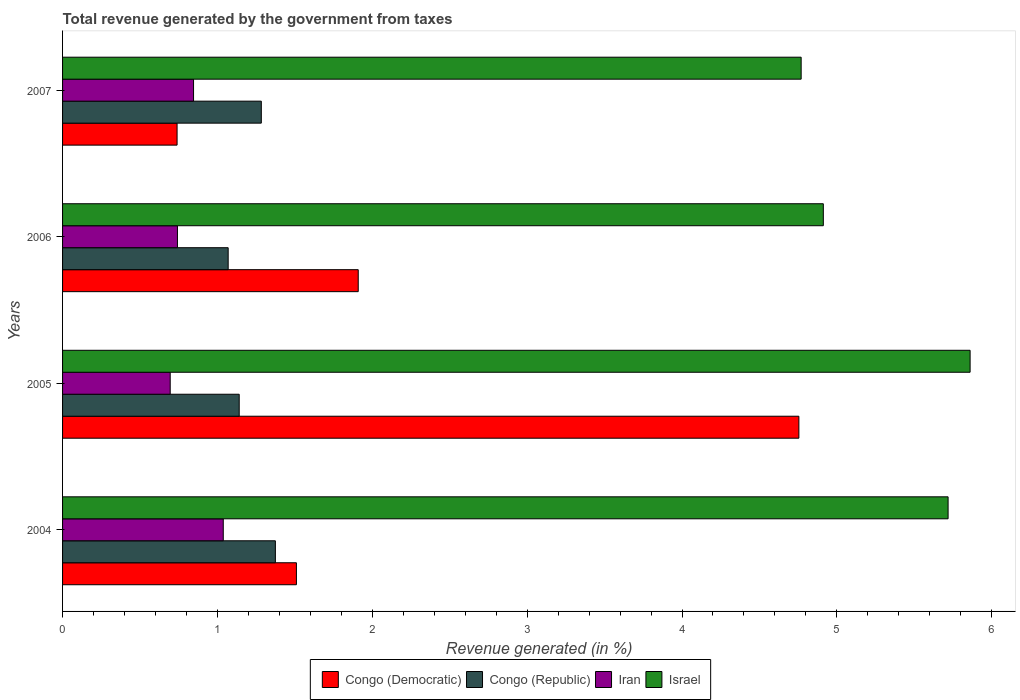How many different coloured bars are there?
Make the answer very short. 4. How many groups of bars are there?
Offer a very short reply. 4. Are the number of bars per tick equal to the number of legend labels?
Offer a very short reply. Yes. What is the total revenue generated in Israel in 2005?
Your answer should be compact. 5.86. Across all years, what is the maximum total revenue generated in Congo (Republic)?
Give a very brief answer. 1.37. Across all years, what is the minimum total revenue generated in Congo (Republic)?
Offer a terse response. 1.07. In which year was the total revenue generated in Israel maximum?
Provide a succinct answer. 2005. What is the total total revenue generated in Congo (Democratic) in the graph?
Your answer should be compact. 8.91. What is the difference between the total revenue generated in Congo (Republic) in 2004 and that in 2005?
Offer a very short reply. 0.23. What is the difference between the total revenue generated in Iran in 2005 and the total revenue generated in Congo (Republic) in 2007?
Make the answer very short. -0.59. What is the average total revenue generated in Iran per year?
Provide a succinct answer. 0.83. In the year 2007, what is the difference between the total revenue generated in Iran and total revenue generated in Israel?
Your answer should be compact. -3.92. What is the ratio of the total revenue generated in Iran in 2004 to that in 2005?
Make the answer very short. 1.49. Is the difference between the total revenue generated in Iran in 2005 and 2007 greater than the difference between the total revenue generated in Israel in 2005 and 2007?
Give a very brief answer. No. What is the difference between the highest and the second highest total revenue generated in Congo (Republic)?
Offer a very short reply. 0.09. What is the difference between the highest and the lowest total revenue generated in Israel?
Make the answer very short. 1.09. Is the sum of the total revenue generated in Congo (Republic) in 2004 and 2006 greater than the maximum total revenue generated in Israel across all years?
Keep it short and to the point. No. Is it the case that in every year, the sum of the total revenue generated in Congo (Democratic) and total revenue generated in Congo (Republic) is greater than the sum of total revenue generated in Israel and total revenue generated in Iran?
Provide a short and direct response. No. What does the 4th bar from the top in 2006 represents?
Offer a very short reply. Congo (Democratic). What does the 1st bar from the bottom in 2005 represents?
Offer a very short reply. Congo (Democratic). How many bars are there?
Provide a short and direct response. 16. Are all the bars in the graph horizontal?
Your response must be concise. Yes. What is the difference between two consecutive major ticks on the X-axis?
Provide a succinct answer. 1. Are the values on the major ticks of X-axis written in scientific E-notation?
Your response must be concise. No. Does the graph contain any zero values?
Your answer should be compact. No. Does the graph contain grids?
Make the answer very short. No. How are the legend labels stacked?
Give a very brief answer. Horizontal. What is the title of the graph?
Your answer should be compact. Total revenue generated by the government from taxes. What is the label or title of the X-axis?
Keep it short and to the point. Revenue generated (in %). What is the label or title of the Y-axis?
Make the answer very short. Years. What is the Revenue generated (in %) of Congo (Democratic) in 2004?
Offer a very short reply. 1.51. What is the Revenue generated (in %) of Congo (Republic) in 2004?
Offer a very short reply. 1.37. What is the Revenue generated (in %) of Iran in 2004?
Your answer should be compact. 1.04. What is the Revenue generated (in %) in Israel in 2004?
Provide a short and direct response. 5.72. What is the Revenue generated (in %) in Congo (Democratic) in 2005?
Your answer should be compact. 4.75. What is the Revenue generated (in %) in Congo (Republic) in 2005?
Offer a very short reply. 1.14. What is the Revenue generated (in %) in Iran in 2005?
Provide a succinct answer. 0.7. What is the Revenue generated (in %) of Israel in 2005?
Your response must be concise. 5.86. What is the Revenue generated (in %) of Congo (Democratic) in 2006?
Provide a short and direct response. 1.91. What is the Revenue generated (in %) in Congo (Republic) in 2006?
Provide a succinct answer. 1.07. What is the Revenue generated (in %) of Iran in 2006?
Your answer should be very brief. 0.74. What is the Revenue generated (in %) in Israel in 2006?
Provide a short and direct response. 4.91. What is the Revenue generated (in %) in Congo (Democratic) in 2007?
Offer a terse response. 0.74. What is the Revenue generated (in %) of Congo (Republic) in 2007?
Your response must be concise. 1.28. What is the Revenue generated (in %) of Iran in 2007?
Your response must be concise. 0.85. What is the Revenue generated (in %) of Israel in 2007?
Your answer should be compact. 4.77. Across all years, what is the maximum Revenue generated (in %) of Congo (Democratic)?
Ensure brevity in your answer.  4.75. Across all years, what is the maximum Revenue generated (in %) in Congo (Republic)?
Keep it short and to the point. 1.37. Across all years, what is the maximum Revenue generated (in %) in Iran?
Keep it short and to the point. 1.04. Across all years, what is the maximum Revenue generated (in %) of Israel?
Keep it short and to the point. 5.86. Across all years, what is the minimum Revenue generated (in %) of Congo (Democratic)?
Ensure brevity in your answer.  0.74. Across all years, what is the minimum Revenue generated (in %) in Congo (Republic)?
Ensure brevity in your answer.  1.07. Across all years, what is the minimum Revenue generated (in %) in Iran?
Offer a terse response. 0.7. Across all years, what is the minimum Revenue generated (in %) in Israel?
Offer a terse response. 4.77. What is the total Revenue generated (in %) in Congo (Democratic) in the graph?
Keep it short and to the point. 8.91. What is the total Revenue generated (in %) in Congo (Republic) in the graph?
Provide a succinct answer. 4.87. What is the total Revenue generated (in %) of Iran in the graph?
Your response must be concise. 3.32. What is the total Revenue generated (in %) of Israel in the graph?
Offer a terse response. 21.26. What is the difference between the Revenue generated (in %) of Congo (Democratic) in 2004 and that in 2005?
Make the answer very short. -3.24. What is the difference between the Revenue generated (in %) of Congo (Republic) in 2004 and that in 2005?
Your answer should be very brief. 0.23. What is the difference between the Revenue generated (in %) of Iran in 2004 and that in 2005?
Make the answer very short. 0.34. What is the difference between the Revenue generated (in %) of Israel in 2004 and that in 2005?
Your answer should be very brief. -0.14. What is the difference between the Revenue generated (in %) in Congo (Democratic) in 2004 and that in 2006?
Make the answer very short. -0.4. What is the difference between the Revenue generated (in %) of Congo (Republic) in 2004 and that in 2006?
Offer a very short reply. 0.3. What is the difference between the Revenue generated (in %) in Iran in 2004 and that in 2006?
Provide a succinct answer. 0.3. What is the difference between the Revenue generated (in %) in Israel in 2004 and that in 2006?
Your response must be concise. 0.81. What is the difference between the Revenue generated (in %) of Congo (Democratic) in 2004 and that in 2007?
Your answer should be very brief. 0.77. What is the difference between the Revenue generated (in %) of Congo (Republic) in 2004 and that in 2007?
Offer a very short reply. 0.09. What is the difference between the Revenue generated (in %) of Iran in 2004 and that in 2007?
Ensure brevity in your answer.  0.19. What is the difference between the Revenue generated (in %) of Israel in 2004 and that in 2007?
Offer a very short reply. 0.95. What is the difference between the Revenue generated (in %) in Congo (Democratic) in 2005 and that in 2006?
Make the answer very short. 2.85. What is the difference between the Revenue generated (in %) in Congo (Republic) in 2005 and that in 2006?
Offer a very short reply. 0.07. What is the difference between the Revenue generated (in %) in Iran in 2005 and that in 2006?
Your response must be concise. -0.05. What is the difference between the Revenue generated (in %) in Israel in 2005 and that in 2006?
Your answer should be very brief. 0.95. What is the difference between the Revenue generated (in %) of Congo (Democratic) in 2005 and that in 2007?
Ensure brevity in your answer.  4.02. What is the difference between the Revenue generated (in %) of Congo (Republic) in 2005 and that in 2007?
Provide a short and direct response. -0.14. What is the difference between the Revenue generated (in %) in Iran in 2005 and that in 2007?
Offer a terse response. -0.15. What is the difference between the Revenue generated (in %) in Israel in 2005 and that in 2007?
Offer a terse response. 1.09. What is the difference between the Revenue generated (in %) of Congo (Democratic) in 2006 and that in 2007?
Provide a short and direct response. 1.17. What is the difference between the Revenue generated (in %) in Congo (Republic) in 2006 and that in 2007?
Provide a short and direct response. -0.21. What is the difference between the Revenue generated (in %) of Iran in 2006 and that in 2007?
Ensure brevity in your answer.  -0.1. What is the difference between the Revenue generated (in %) of Israel in 2006 and that in 2007?
Ensure brevity in your answer.  0.14. What is the difference between the Revenue generated (in %) in Congo (Democratic) in 2004 and the Revenue generated (in %) in Congo (Republic) in 2005?
Your response must be concise. 0.37. What is the difference between the Revenue generated (in %) of Congo (Democratic) in 2004 and the Revenue generated (in %) of Iran in 2005?
Keep it short and to the point. 0.81. What is the difference between the Revenue generated (in %) of Congo (Democratic) in 2004 and the Revenue generated (in %) of Israel in 2005?
Ensure brevity in your answer.  -4.35. What is the difference between the Revenue generated (in %) in Congo (Republic) in 2004 and the Revenue generated (in %) in Iran in 2005?
Give a very brief answer. 0.68. What is the difference between the Revenue generated (in %) of Congo (Republic) in 2004 and the Revenue generated (in %) of Israel in 2005?
Your answer should be compact. -4.49. What is the difference between the Revenue generated (in %) of Iran in 2004 and the Revenue generated (in %) of Israel in 2005?
Ensure brevity in your answer.  -4.82. What is the difference between the Revenue generated (in %) in Congo (Democratic) in 2004 and the Revenue generated (in %) in Congo (Republic) in 2006?
Offer a terse response. 0.44. What is the difference between the Revenue generated (in %) of Congo (Democratic) in 2004 and the Revenue generated (in %) of Iran in 2006?
Provide a succinct answer. 0.77. What is the difference between the Revenue generated (in %) of Congo (Democratic) in 2004 and the Revenue generated (in %) of Israel in 2006?
Keep it short and to the point. -3.4. What is the difference between the Revenue generated (in %) of Congo (Republic) in 2004 and the Revenue generated (in %) of Iran in 2006?
Give a very brief answer. 0.63. What is the difference between the Revenue generated (in %) in Congo (Republic) in 2004 and the Revenue generated (in %) in Israel in 2006?
Provide a succinct answer. -3.54. What is the difference between the Revenue generated (in %) in Iran in 2004 and the Revenue generated (in %) in Israel in 2006?
Ensure brevity in your answer.  -3.87. What is the difference between the Revenue generated (in %) of Congo (Democratic) in 2004 and the Revenue generated (in %) of Congo (Republic) in 2007?
Your answer should be compact. 0.23. What is the difference between the Revenue generated (in %) of Congo (Democratic) in 2004 and the Revenue generated (in %) of Iran in 2007?
Provide a short and direct response. 0.66. What is the difference between the Revenue generated (in %) of Congo (Democratic) in 2004 and the Revenue generated (in %) of Israel in 2007?
Keep it short and to the point. -3.26. What is the difference between the Revenue generated (in %) of Congo (Republic) in 2004 and the Revenue generated (in %) of Iran in 2007?
Provide a short and direct response. 0.53. What is the difference between the Revenue generated (in %) of Congo (Republic) in 2004 and the Revenue generated (in %) of Israel in 2007?
Your answer should be very brief. -3.4. What is the difference between the Revenue generated (in %) of Iran in 2004 and the Revenue generated (in %) of Israel in 2007?
Provide a short and direct response. -3.73. What is the difference between the Revenue generated (in %) in Congo (Democratic) in 2005 and the Revenue generated (in %) in Congo (Republic) in 2006?
Provide a succinct answer. 3.69. What is the difference between the Revenue generated (in %) in Congo (Democratic) in 2005 and the Revenue generated (in %) in Iran in 2006?
Provide a short and direct response. 4.01. What is the difference between the Revenue generated (in %) in Congo (Democratic) in 2005 and the Revenue generated (in %) in Israel in 2006?
Provide a short and direct response. -0.16. What is the difference between the Revenue generated (in %) of Congo (Republic) in 2005 and the Revenue generated (in %) of Iran in 2006?
Ensure brevity in your answer.  0.4. What is the difference between the Revenue generated (in %) in Congo (Republic) in 2005 and the Revenue generated (in %) in Israel in 2006?
Offer a terse response. -3.77. What is the difference between the Revenue generated (in %) of Iran in 2005 and the Revenue generated (in %) of Israel in 2006?
Provide a short and direct response. -4.22. What is the difference between the Revenue generated (in %) of Congo (Democratic) in 2005 and the Revenue generated (in %) of Congo (Republic) in 2007?
Make the answer very short. 3.47. What is the difference between the Revenue generated (in %) of Congo (Democratic) in 2005 and the Revenue generated (in %) of Iran in 2007?
Make the answer very short. 3.91. What is the difference between the Revenue generated (in %) in Congo (Democratic) in 2005 and the Revenue generated (in %) in Israel in 2007?
Offer a terse response. -0.01. What is the difference between the Revenue generated (in %) of Congo (Republic) in 2005 and the Revenue generated (in %) of Iran in 2007?
Your answer should be very brief. 0.29. What is the difference between the Revenue generated (in %) in Congo (Republic) in 2005 and the Revenue generated (in %) in Israel in 2007?
Provide a short and direct response. -3.63. What is the difference between the Revenue generated (in %) of Iran in 2005 and the Revenue generated (in %) of Israel in 2007?
Your response must be concise. -4.07. What is the difference between the Revenue generated (in %) in Congo (Democratic) in 2006 and the Revenue generated (in %) in Congo (Republic) in 2007?
Provide a short and direct response. 0.63. What is the difference between the Revenue generated (in %) of Congo (Democratic) in 2006 and the Revenue generated (in %) of Iran in 2007?
Give a very brief answer. 1.06. What is the difference between the Revenue generated (in %) in Congo (Democratic) in 2006 and the Revenue generated (in %) in Israel in 2007?
Keep it short and to the point. -2.86. What is the difference between the Revenue generated (in %) of Congo (Republic) in 2006 and the Revenue generated (in %) of Iran in 2007?
Offer a very short reply. 0.22. What is the difference between the Revenue generated (in %) in Congo (Republic) in 2006 and the Revenue generated (in %) in Israel in 2007?
Your response must be concise. -3.7. What is the difference between the Revenue generated (in %) in Iran in 2006 and the Revenue generated (in %) in Israel in 2007?
Provide a succinct answer. -4.03. What is the average Revenue generated (in %) of Congo (Democratic) per year?
Ensure brevity in your answer.  2.23. What is the average Revenue generated (in %) of Congo (Republic) per year?
Provide a short and direct response. 1.22. What is the average Revenue generated (in %) of Iran per year?
Provide a succinct answer. 0.83. What is the average Revenue generated (in %) in Israel per year?
Keep it short and to the point. 5.32. In the year 2004, what is the difference between the Revenue generated (in %) in Congo (Democratic) and Revenue generated (in %) in Congo (Republic)?
Provide a short and direct response. 0.14. In the year 2004, what is the difference between the Revenue generated (in %) of Congo (Democratic) and Revenue generated (in %) of Iran?
Make the answer very short. 0.47. In the year 2004, what is the difference between the Revenue generated (in %) in Congo (Democratic) and Revenue generated (in %) in Israel?
Keep it short and to the point. -4.21. In the year 2004, what is the difference between the Revenue generated (in %) of Congo (Republic) and Revenue generated (in %) of Iran?
Your response must be concise. 0.34. In the year 2004, what is the difference between the Revenue generated (in %) in Congo (Republic) and Revenue generated (in %) in Israel?
Your answer should be compact. -4.34. In the year 2004, what is the difference between the Revenue generated (in %) in Iran and Revenue generated (in %) in Israel?
Provide a short and direct response. -4.68. In the year 2005, what is the difference between the Revenue generated (in %) of Congo (Democratic) and Revenue generated (in %) of Congo (Republic)?
Provide a short and direct response. 3.61. In the year 2005, what is the difference between the Revenue generated (in %) in Congo (Democratic) and Revenue generated (in %) in Iran?
Offer a very short reply. 4.06. In the year 2005, what is the difference between the Revenue generated (in %) of Congo (Democratic) and Revenue generated (in %) of Israel?
Provide a short and direct response. -1.11. In the year 2005, what is the difference between the Revenue generated (in %) in Congo (Republic) and Revenue generated (in %) in Iran?
Make the answer very short. 0.45. In the year 2005, what is the difference between the Revenue generated (in %) of Congo (Republic) and Revenue generated (in %) of Israel?
Make the answer very short. -4.72. In the year 2005, what is the difference between the Revenue generated (in %) in Iran and Revenue generated (in %) in Israel?
Offer a terse response. -5.17. In the year 2006, what is the difference between the Revenue generated (in %) in Congo (Democratic) and Revenue generated (in %) in Congo (Republic)?
Ensure brevity in your answer.  0.84. In the year 2006, what is the difference between the Revenue generated (in %) of Congo (Democratic) and Revenue generated (in %) of Iran?
Your answer should be very brief. 1.17. In the year 2006, what is the difference between the Revenue generated (in %) in Congo (Democratic) and Revenue generated (in %) in Israel?
Provide a short and direct response. -3. In the year 2006, what is the difference between the Revenue generated (in %) of Congo (Republic) and Revenue generated (in %) of Iran?
Your answer should be very brief. 0.33. In the year 2006, what is the difference between the Revenue generated (in %) of Congo (Republic) and Revenue generated (in %) of Israel?
Your response must be concise. -3.84. In the year 2006, what is the difference between the Revenue generated (in %) of Iran and Revenue generated (in %) of Israel?
Offer a very short reply. -4.17. In the year 2007, what is the difference between the Revenue generated (in %) in Congo (Democratic) and Revenue generated (in %) in Congo (Republic)?
Your answer should be compact. -0.54. In the year 2007, what is the difference between the Revenue generated (in %) of Congo (Democratic) and Revenue generated (in %) of Iran?
Provide a short and direct response. -0.11. In the year 2007, what is the difference between the Revenue generated (in %) of Congo (Democratic) and Revenue generated (in %) of Israel?
Your response must be concise. -4.03. In the year 2007, what is the difference between the Revenue generated (in %) of Congo (Republic) and Revenue generated (in %) of Iran?
Make the answer very short. 0.44. In the year 2007, what is the difference between the Revenue generated (in %) in Congo (Republic) and Revenue generated (in %) in Israel?
Offer a terse response. -3.49. In the year 2007, what is the difference between the Revenue generated (in %) in Iran and Revenue generated (in %) in Israel?
Give a very brief answer. -3.92. What is the ratio of the Revenue generated (in %) in Congo (Democratic) in 2004 to that in 2005?
Offer a very short reply. 0.32. What is the ratio of the Revenue generated (in %) in Congo (Republic) in 2004 to that in 2005?
Offer a very short reply. 1.2. What is the ratio of the Revenue generated (in %) in Iran in 2004 to that in 2005?
Keep it short and to the point. 1.49. What is the ratio of the Revenue generated (in %) in Israel in 2004 to that in 2005?
Your answer should be compact. 0.98. What is the ratio of the Revenue generated (in %) in Congo (Democratic) in 2004 to that in 2006?
Offer a terse response. 0.79. What is the ratio of the Revenue generated (in %) in Congo (Republic) in 2004 to that in 2006?
Offer a very short reply. 1.29. What is the ratio of the Revenue generated (in %) in Iran in 2004 to that in 2006?
Your answer should be compact. 1.4. What is the ratio of the Revenue generated (in %) of Israel in 2004 to that in 2006?
Offer a terse response. 1.16. What is the ratio of the Revenue generated (in %) in Congo (Democratic) in 2004 to that in 2007?
Provide a short and direct response. 2.04. What is the ratio of the Revenue generated (in %) of Congo (Republic) in 2004 to that in 2007?
Offer a terse response. 1.07. What is the ratio of the Revenue generated (in %) of Iran in 2004 to that in 2007?
Your response must be concise. 1.23. What is the ratio of the Revenue generated (in %) of Israel in 2004 to that in 2007?
Your answer should be very brief. 1.2. What is the ratio of the Revenue generated (in %) in Congo (Democratic) in 2005 to that in 2006?
Offer a very short reply. 2.49. What is the ratio of the Revenue generated (in %) of Congo (Republic) in 2005 to that in 2006?
Your answer should be very brief. 1.07. What is the ratio of the Revenue generated (in %) of Iran in 2005 to that in 2006?
Keep it short and to the point. 0.94. What is the ratio of the Revenue generated (in %) in Israel in 2005 to that in 2006?
Provide a succinct answer. 1.19. What is the ratio of the Revenue generated (in %) in Congo (Democratic) in 2005 to that in 2007?
Offer a terse response. 6.43. What is the ratio of the Revenue generated (in %) of Congo (Republic) in 2005 to that in 2007?
Give a very brief answer. 0.89. What is the ratio of the Revenue generated (in %) in Iran in 2005 to that in 2007?
Give a very brief answer. 0.82. What is the ratio of the Revenue generated (in %) in Israel in 2005 to that in 2007?
Keep it short and to the point. 1.23. What is the ratio of the Revenue generated (in %) of Congo (Democratic) in 2006 to that in 2007?
Ensure brevity in your answer.  2.58. What is the ratio of the Revenue generated (in %) in Congo (Republic) in 2006 to that in 2007?
Make the answer very short. 0.83. What is the ratio of the Revenue generated (in %) in Iran in 2006 to that in 2007?
Your response must be concise. 0.88. What is the difference between the highest and the second highest Revenue generated (in %) in Congo (Democratic)?
Ensure brevity in your answer.  2.85. What is the difference between the highest and the second highest Revenue generated (in %) of Congo (Republic)?
Offer a terse response. 0.09. What is the difference between the highest and the second highest Revenue generated (in %) of Iran?
Provide a short and direct response. 0.19. What is the difference between the highest and the second highest Revenue generated (in %) in Israel?
Keep it short and to the point. 0.14. What is the difference between the highest and the lowest Revenue generated (in %) of Congo (Democratic)?
Offer a terse response. 4.02. What is the difference between the highest and the lowest Revenue generated (in %) in Congo (Republic)?
Provide a succinct answer. 0.3. What is the difference between the highest and the lowest Revenue generated (in %) of Iran?
Offer a terse response. 0.34. What is the difference between the highest and the lowest Revenue generated (in %) in Israel?
Ensure brevity in your answer.  1.09. 